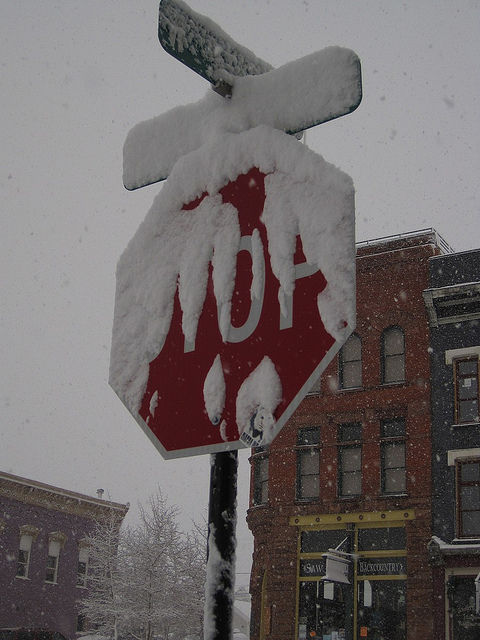<image>Which sign is not covered in snow? It is uncertain which sign is not covered in snow. It could be the stop sign.
 Which sign is not covered in snow? It is ambiguous which sign is not covered in snow. It can be any of the signs. 